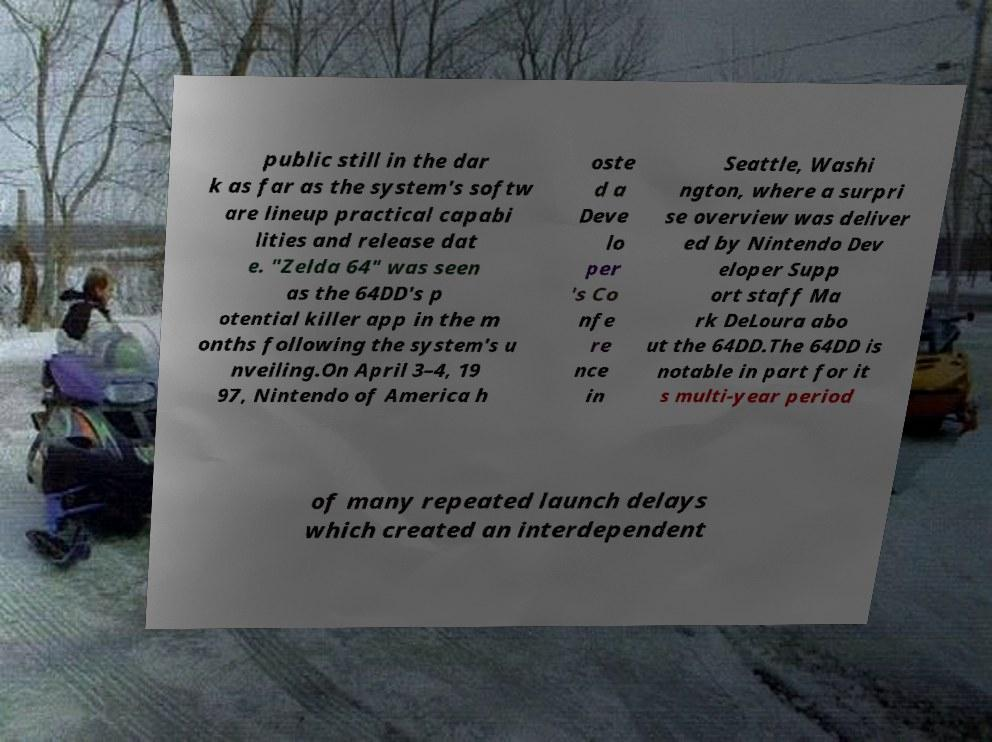Can you read and provide the text displayed in the image?This photo seems to have some interesting text. Can you extract and type it out for me? public still in the dar k as far as the system's softw are lineup practical capabi lities and release dat e. "Zelda 64" was seen as the 64DD's p otential killer app in the m onths following the system's u nveiling.On April 3–4, 19 97, Nintendo of America h oste d a Deve lo per 's Co nfe re nce in Seattle, Washi ngton, where a surpri se overview was deliver ed by Nintendo Dev eloper Supp ort staff Ma rk DeLoura abo ut the 64DD.The 64DD is notable in part for it s multi-year period of many repeated launch delays which created an interdependent 